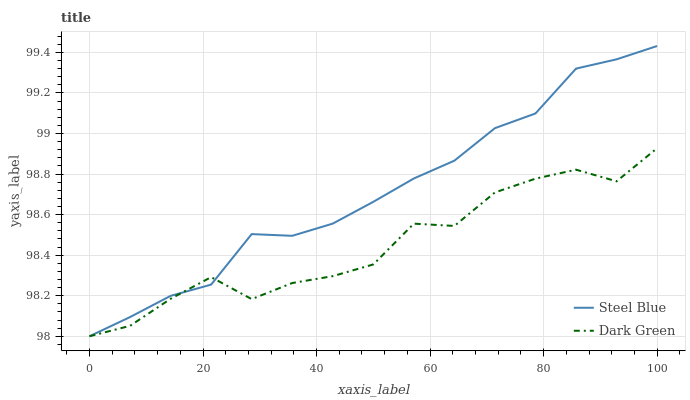Does Dark Green have the minimum area under the curve?
Answer yes or no. Yes. Does Steel Blue have the maximum area under the curve?
Answer yes or no. Yes. Does Dark Green have the maximum area under the curve?
Answer yes or no. No. Is Steel Blue the smoothest?
Answer yes or no. Yes. Is Dark Green the roughest?
Answer yes or no. Yes. Is Dark Green the smoothest?
Answer yes or no. No. Does Dark Green have the highest value?
Answer yes or no. No. 